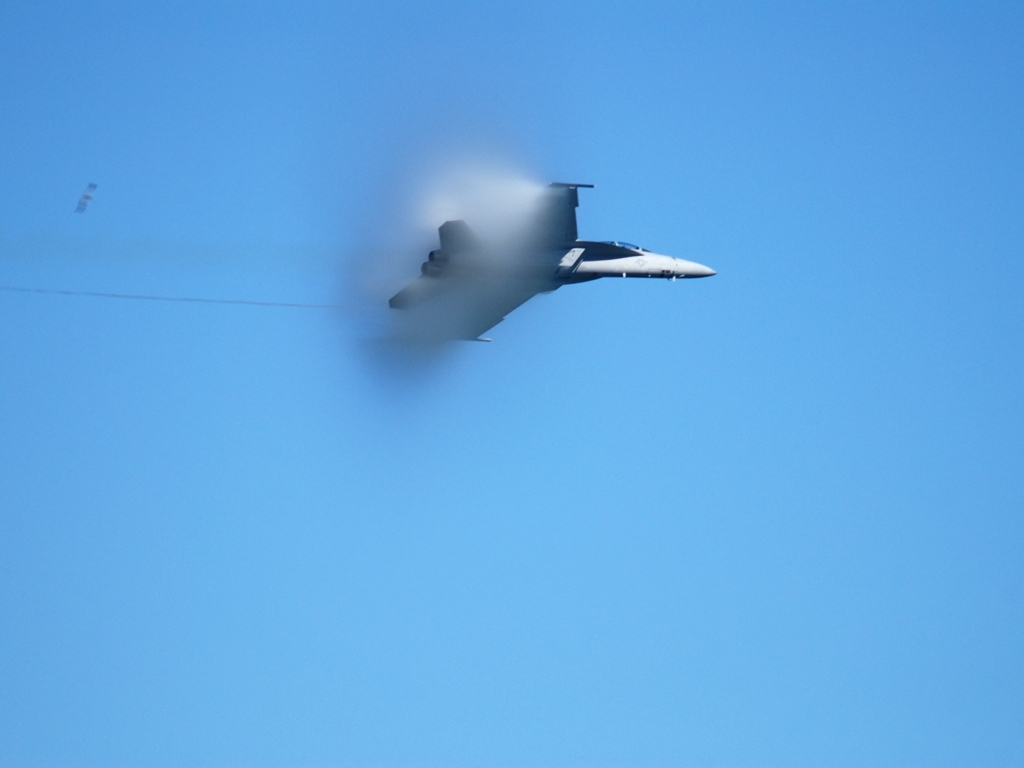Could you explain what kind of maneuvers might cause such vapor trails? Vapor trails like the one seen in this image often occur during high-speed, high-angle maneuvers where the air pressure around the aircraft changes rapidly. Such maneuvers include sudden climbs, sharp turns, or rapid acceleration, which can cause the air to condense into visible trails or clouds. 